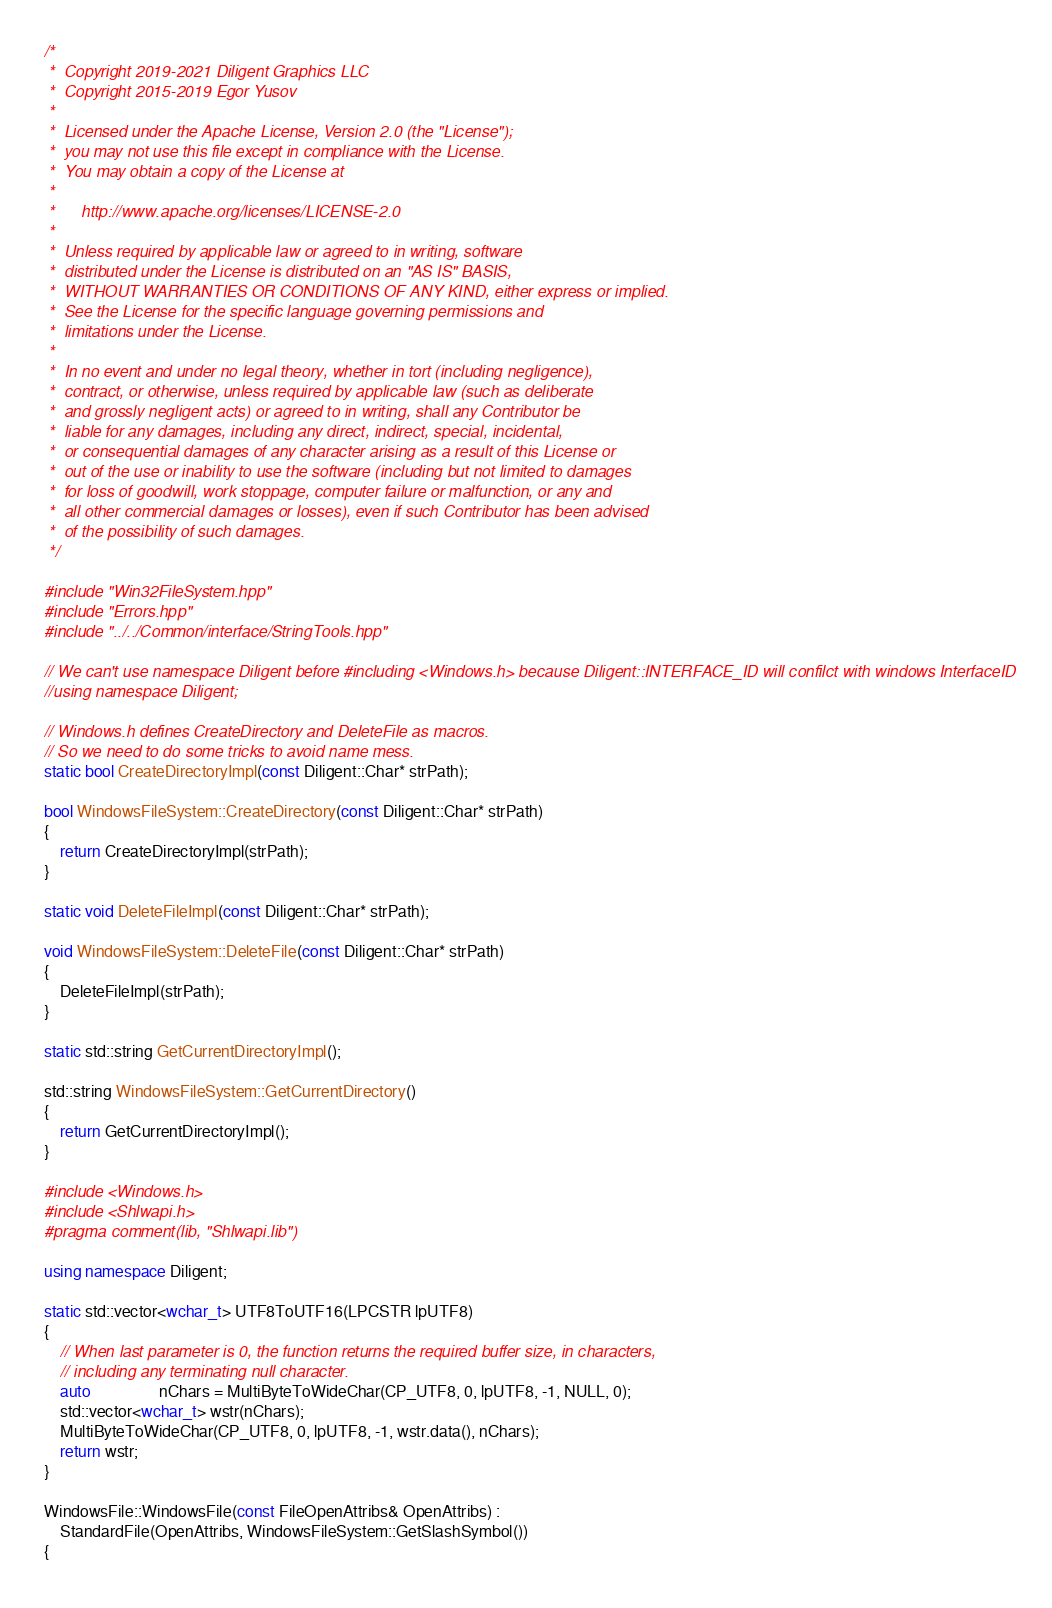<code> <loc_0><loc_0><loc_500><loc_500><_C++_>/*
 *  Copyright 2019-2021 Diligent Graphics LLC
 *  Copyright 2015-2019 Egor Yusov
 *  
 *  Licensed under the Apache License, Version 2.0 (the "License");
 *  you may not use this file except in compliance with the License.
 *  You may obtain a copy of the License at
 *  
 *      http://www.apache.org/licenses/LICENSE-2.0
 *  
 *  Unless required by applicable law or agreed to in writing, software
 *  distributed under the License is distributed on an "AS IS" BASIS,
 *  WITHOUT WARRANTIES OR CONDITIONS OF ANY KIND, either express or implied.
 *  See the License for the specific language governing permissions and
 *  limitations under the License.
 *
 *  In no event and under no legal theory, whether in tort (including negligence), 
 *  contract, or otherwise, unless required by applicable law (such as deliberate 
 *  and grossly negligent acts) or agreed to in writing, shall any Contributor be
 *  liable for any damages, including any direct, indirect, special, incidental, 
 *  or consequential damages of any character arising as a result of this License or 
 *  out of the use or inability to use the software (including but not limited to damages 
 *  for loss of goodwill, work stoppage, computer failure or malfunction, or any and 
 *  all other commercial damages or losses), even if such Contributor has been advised 
 *  of the possibility of such damages.
 */

#include "Win32FileSystem.hpp"
#include "Errors.hpp"
#include "../../Common/interface/StringTools.hpp"

// We can't use namespace Diligent before #including <Windows.h> because Diligent::INTERFACE_ID will confilct with windows InterfaceID
//using namespace Diligent;

// Windows.h defines CreateDirectory and DeleteFile as macros.
// So we need to do some tricks to avoid name mess.
static bool CreateDirectoryImpl(const Diligent::Char* strPath);

bool WindowsFileSystem::CreateDirectory(const Diligent::Char* strPath)
{
    return CreateDirectoryImpl(strPath);
}

static void DeleteFileImpl(const Diligent::Char* strPath);

void WindowsFileSystem::DeleteFile(const Diligent::Char* strPath)
{
    DeleteFileImpl(strPath);
}

static std::string GetCurrentDirectoryImpl();

std::string WindowsFileSystem::GetCurrentDirectory()
{
    return GetCurrentDirectoryImpl();
}

#include <Windows.h>
#include <Shlwapi.h>
#pragma comment(lib, "Shlwapi.lib")

using namespace Diligent;

static std::vector<wchar_t> UTF8ToUTF16(LPCSTR lpUTF8)
{
    // When last parameter is 0, the function returns the required buffer size, in characters,
    // including any terminating null character.
    auto                 nChars = MultiByteToWideChar(CP_UTF8, 0, lpUTF8, -1, NULL, 0);
    std::vector<wchar_t> wstr(nChars);
    MultiByteToWideChar(CP_UTF8, 0, lpUTF8, -1, wstr.data(), nChars);
    return wstr;
}

WindowsFile::WindowsFile(const FileOpenAttribs& OpenAttribs) :
    StandardFile(OpenAttribs, WindowsFileSystem::GetSlashSymbol())
{</code> 